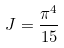<formula> <loc_0><loc_0><loc_500><loc_500>J = \frac { \pi ^ { 4 } } { 1 5 }</formula> 